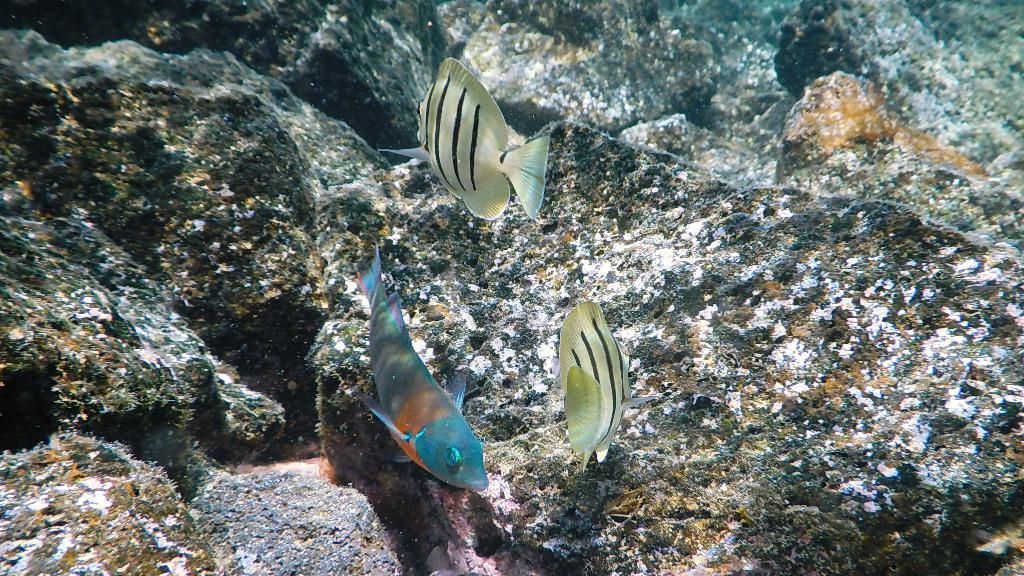Could you give a brief overview of what you see in this image? In this image there are three fish in the water, beside them we can see the stones. 